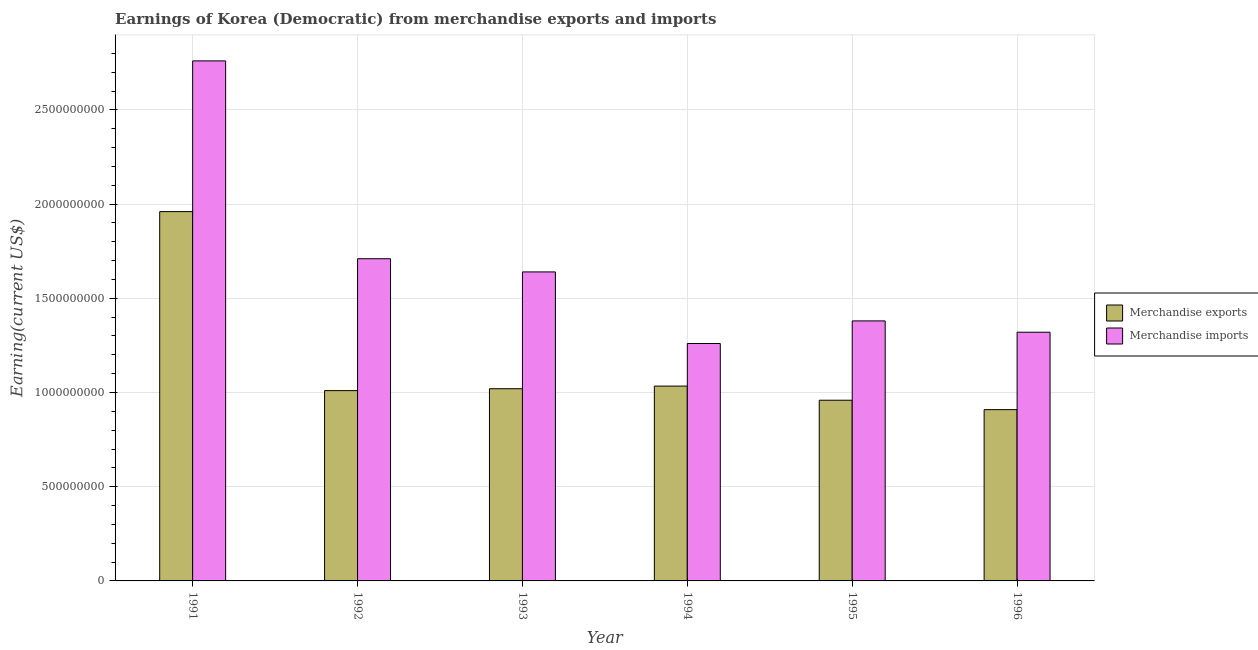Are the number of bars per tick equal to the number of legend labels?
Ensure brevity in your answer.  Yes. Are the number of bars on each tick of the X-axis equal?
Keep it short and to the point. Yes. How many bars are there on the 4th tick from the left?
Your answer should be compact. 2. What is the earnings from merchandise imports in 1993?
Offer a terse response. 1.64e+09. Across all years, what is the maximum earnings from merchandise imports?
Your answer should be compact. 2.76e+09. Across all years, what is the minimum earnings from merchandise exports?
Provide a succinct answer. 9.09e+08. In which year was the earnings from merchandise exports maximum?
Ensure brevity in your answer.  1991. In which year was the earnings from merchandise imports minimum?
Your answer should be very brief. 1994. What is the total earnings from merchandise exports in the graph?
Provide a succinct answer. 6.89e+09. What is the difference between the earnings from merchandise imports in 1994 and that in 1995?
Keep it short and to the point. -1.20e+08. What is the difference between the earnings from merchandise imports in 1994 and the earnings from merchandise exports in 1993?
Offer a very short reply. -3.80e+08. What is the average earnings from merchandise imports per year?
Your answer should be compact. 1.68e+09. In the year 1991, what is the difference between the earnings from merchandise exports and earnings from merchandise imports?
Offer a very short reply. 0. What is the ratio of the earnings from merchandise imports in 1993 to that in 1994?
Make the answer very short. 1.3. Is the earnings from merchandise imports in 1992 less than that in 1993?
Offer a terse response. No. What is the difference between the highest and the second highest earnings from merchandise exports?
Your response must be concise. 9.26e+08. What is the difference between the highest and the lowest earnings from merchandise imports?
Provide a short and direct response. 1.50e+09. In how many years, is the earnings from merchandise imports greater than the average earnings from merchandise imports taken over all years?
Give a very brief answer. 2. What does the 1st bar from the left in 1995 represents?
Keep it short and to the point. Merchandise exports. What does the 2nd bar from the right in 1995 represents?
Your answer should be very brief. Merchandise exports. How many bars are there?
Your answer should be very brief. 12. Are all the bars in the graph horizontal?
Your response must be concise. No. Does the graph contain grids?
Provide a succinct answer. Yes. How many legend labels are there?
Offer a terse response. 2. What is the title of the graph?
Give a very brief answer. Earnings of Korea (Democratic) from merchandise exports and imports. What is the label or title of the Y-axis?
Your answer should be compact. Earning(current US$). What is the Earning(current US$) of Merchandise exports in 1991?
Provide a succinct answer. 1.96e+09. What is the Earning(current US$) of Merchandise imports in 1991?
Provide a short and direct response. 2.76e+09. What is the Earning(current US$) of Merchandise exports in 1992?
Provide a short and direct response. 1.01e+09. What is the Earning(current US$) of Merchandise imports in 1992?
Offer a terse response. 1.71e+09. What is the Earning(current US$) in Merchandise exports in 1993?
Offer a terse response. 1.02e+09. What is the Earning(current US$) of Merchandise imports in 1993?
Provide a short and direct response. 1.64e+09. What is the Earning(current US$) in Merchandise exports in 1994?
Keep it short and to the point. 1.03e+09. What is the Earning(current US$) of Merchandise imports in 1994?
Offer a terse response. 1.26e+09. What is the Earning(current US$) in Merchandise exports in 1995?
Provide a succinct answer. 9.59e+08. What is the Earning(current US$) in Merchandise imports in 1995?
Your response must be concise. 1.38e+09. What is the Earning(current US$) in Merchandise exports in 1996?
Offer a terse response. 9.09e+08. What is the Earning(current US$) of Merchandise imports in 1996?
Offer a very short reply. 1.32e+09. Across all years, what is the maximum Earning(current US$) in Merchandise exports?
Offer a very short reply. 1.96e+09. Across all years, what is the maximum Earning(current US$) in Merchandise imports?
Give a very brief answer. 2.76e+09. Across all years, what is the minimum Earning(current US$) of Merchandise exports?
Your answer should be very brief. 9.09e+08. Across all years, what is the minimum Earning(current US$) of Merchandise imports?
Provide a short and direct response. 1.26e+09. What is the total Earning(current US$) in Merchandise exports in the graph?
Make the answer very short. 6.89e+09. What is the total Earning(current US$) in Merchandise imports in the graph?
Make the answer very short. 1.01e+1. What is the difference between the Earning(current US$) in Merchandise exports in 1991 and that in 1992?
Provide a succinct answer. 9.50e+08. What is the difference between the Earning(current US$) of Merchandise imports in 1991 and that in 1992?
Your answer should be compact. 1.05e+09. What is the difference between the Earning(current US$) of Merchandise exports in 1991 and that in 1993?
Keep it short and to the point. 9.40e+08. What is the difference between the Earning(current US$) in Merchandise imports in 1991 and that in 1993?
Your answer should be very brief. 1.12e+09. What is the difference between the Earning(current US$) of Merchandise exports in 1991 and that in 1994?
Provide a succinct answer. 9.26e+08. What is the difference between the Earning(current US$) in Merchandise imports in 1991 and that in 1994?
Your response must be concise. 1.50e+09. What is the difference between the Earning(current US$) in Merchandise exports in 1991 and that in 1995?
Make the answer very short. 1.00e+09. What is the difference between the Earning(current US$) in Merchandise imports in 1991 and that in 1995?
Make the answer very short. 1.38e+09. What is the difference between the Earning(current US$) of Merchandise exports in 1991 and that in 1996?
Offer a terse response. 1.05e+09. What is the difference between the Earning(current US$) of Merchandise imports in 1991 and that in 1996?
Your response must be concise. 1.44e+09. What is the difference between the Earning(current US$) in Merchandise exports in 1992 and that in 1993?
Ensure brevity in your answer.  -1.00e+07. What is the difference between the Earning(current US$) of Merchandise imports in 1992 and that in 1993?
Offer a terse response. 7.00e+07. What is the difference between the Earning(current US$) in Merchandise exports in 1992 and that in 1994?
Offer a terse response. -2.40e+07. What is the difference between the Earning(current US$) of Merchandise imports in 1992 and that in 1994?
Offer a terse response. 4.50e+08. What is the difference between the Earning(current US$) in Merchandise exports in 1992 and that in 1995?
Provide a short and direct response. 5.10e+07. What is the difference between the Earning(current US$) of Merchandise imports in 1992 and that in 1995?
Provide a succinct answer. 3.30e+08. What is the difference between the Earning(current US$) of Merchandise exports in 1992 and that in 1996?
Offer a terse response. 1.01e+08. What is the difference between the Earning(current US$) of Merchandise imports in 1992 and that in 1996?
Your answer should be compact. 3.90e+08. What is the difference between the Earning(current US$) of Merchandise exports in 1993 and that in 1994?
Your response must be concise. -1.40e+07. What is the difference between the Earning(current US$) of Merchandise imports in 1993 and that in 1994?
Make the answer very short. 3.80e+08. What is the difference between the Earning(current US$) in Merchandise exports in 1993 and that in 1995?
Provide a succinct answer. 6.10e+07. What is the difference between the Earning(current US$) in Merchandise imports in 1993 and that in 1995?
Give a very brief answer. 2.60e+08. What is the difference between the Earning(current US$) in Merchandise exports in 1993 and that in 1996?
Provide a short and direct response. 1.11e+08. What is the difference between the Earning(current US$) of Merchandise imports in 1993 and that in 1996?
Make the answer very short. 3.20e+08. What is the difference between the Earning(current US$) in Merchandise exports in 1994 and that in 1995?
Give a very brief answer. 7.50e+07. What is the difference between the Earning(current US$) of Merchandise imports in 1994 and that in 1995?
Give a very brief answer. -1.20e+08. What is the difference between the Earning(current US$) of Merchandise exports in 1994 and that in 1996?
Ensure brevity in your answer.  1.25e+08. What is the difference between the Earning(current US$) in Merchandise imports in 1994 and that in 1996?
Make the answer very short. -6.00e+07. What is the difference between the Earning(current US$) of Merchandise exports in 1995 and that in 1996?
Ensure brevity in your answer.  5.00e+07. What is the difference between the Earning(current US$) of Merchandise imports in 1995 and that in 1996?
Provide a short and direct response. 6.00e+07. What is the difference between the Earning(current US$) of Merchandise exports in 1991 and the Earning(current US$) of Merchandise imports in 1992?
Your response must be concise. 2.50e+08. What is the difference between the Earning(current US$) of Merchandise exports in 1991 and the Earning(current US$) of Merchandise imports in 1993?
Offer a terse response. 3.20e+08. What is the difference between the Earning(current US$) of Merchandise exports in 1991 and the Earning(current US$) of Merchandise imports in 1994?
Keep it short and to the point. 7.00e+08. What is the difference between the Earning(current US$) of Merchandise exports in 1991 and the Earning(current US$) of Merchandise imports in 1995?
Your answer should be compact. 5.80e+08. What is the difference between the Earning(current US$) of Merchandise exports in 1991 and the Earning(current US$) of Merchandise imports in 1996?
Ensure brevity in your answer.  6.40e+08. What is the difference between the Earning(current US$) in Merchandise exports in 1992 and the Earning(current US$) in Merchandise imports in 1993?
Provide a short and direct response. -6.30e+08. What is the difference between the Earning(current US$) of Merchandise exports in 1992 and the Earning(current US$) of Merchandise imports in 1994?
Your answer should be very brief. -2.50e+08. What is the difference between the Earning(current US$) in Merchandise exports in 1992 and the Earning(current US$) in Merchandise imports in 1995?
Your response must be concise. -3.70e+08. What is the difference between the Earning(current US$) in Merchandise exports in 1992 and the Earning(current US$) in Merchandise imports in 1996?
Give a very brief answer. -3.10e+08. What is the difference between the Earning(current US$) in Merchandise exports in 1993 and the Earning(current US$) in Merchandise imports in 1994?
Your answer should be compact. -2.40e+08. What is the difference between the Earning(current US$) of Merchandise exports in 1993 and the Earning(current US$) of Merchandise imports in 1995?
Ensure brevity in your answer.  -3.60e+08. What is the difference between the Earning(current US$) of Merchandise exports in 1993 and the Earning(current US$) of Merchandise imports in 1996?
Provide a succinct answer. -3.00e+08. What is the difference between the Earning(current US$) of Merchandise exports in 1994 and the Earning(current US$) of Merchandise imports in 1995?
Your response must be concise. -3.46e+08. What is the difference between the Earning(current US$) of Merchandise exports in 1994 and the Earning(current US$) of Merchandise imports in 1996?
Your answer should be compact. -2.86e+08. What is the difference between the Earning(current US$) of Merchandise exports in 1995 and the Earning(current US$) of Merchandise imports in 1996?
Make the answer very short. -3.61e+08. What is the average Earning(current US$) of Merchandise exports per year?
Offer a terse response. 1.15e+09. What is the average Earning(current US$) of Merchandise imports per year?
Provide a short and direct response. 1.68e+09. In the year 1991, what is the difference between the Earning(current US$) of Merchandise exports and Earning(current US$) of Merchandise imports?
Give a very brief answer. -8.00e+08. In the year 1992, what is the difference between the Earning(current US$) of Merchandise exports and Earning(current US$) of Merchandise imports?
Give a very brief answer. -7.00e+08. In the year 1993, what is the difference between the Earning(current US$) in Merchandise exports and Earning(current US$) in Merchandise imports?
Ensure brevity in your answer.  -6.20e+08. In the year 1994, what is the difference between the Earning(current US$) in Merchandise exports and Earning(current US$) in Merchandise imports?
Provide a short and direct response. -2.26e+08. In the year 1995, what is the difference between the Earning(current US$) of Merchandise exports and Earning(current US$) of Merchandise imports?
Offer a terse response. -4.21e+08. In the year 1996, what is the difference between the Earning(current US$) in Merchandise exports and Earning(current US$) in Merchandise imports?
Provide a short and direct response. -4.11e+08. What is the ratio of the Earning(current US$) of Merchandise exports in 1991 to that in 1992?
Provide a short and direct response. 1.94. What is the ratio of the Earning(current US$) in Merchandise imports in 1991 to that in 1992?
Keep it short and to the point. 1.61. What is the ratio of the Earning(current US$) in Merchandise exports in 1991 to that in 1993?
Give a very brief answer. 1.92. What is the ratio of the Earning(current US$) in Merchandise imports in 1991 to that in 1993?
Give a very brief answer. 1.68. What is the ratio of the Earning(current US$) of Merchandise exports in 1991 to that in 1994?
Make the answer very short. 1.9. What is the ratio of the Earning(current US$) of Merchandise imports in 1991 to that in 1994?
Your answer should be very brief. 2.19. What is the ratio of the Earning(current US$) of Merchandise exports in 1991 to that in 1995?
Your answer should be very brief. 2.04. What is the ratio of the Earning(current US$) in Merchandise exports in 1991 to that in 1996?
Provide a short and direct response. 2.16. What is the ratio of the Earning(current US$) in Merchandise imports in 1991 to that in 1996?
Offer a very short reply. 2.09. What is the ratio of the Earning(current US$) of Merchandise exports in 1992 to that in 1993?
Ensure brevity in your answer.  0.99. What is the ratio of the Earning(current US$) in Merchandise imports in 1992 to that in 1993?
Give a very brief answer. 1.04. What is the ratio of the Earning(current US$) of Merchandise exports in 1992 to that in 1994?
Offer a very short reply. 0.98. What is the ratio of the Earning(current US$) in Merchandise imports in 1992 to that in 1994?
Provide a short and direct response. 1.36. What is the ratio of the Earning(current US$) of Merchandise exports in 1992 to that in 1995?
Offer a very short reply. 1.05. What is the ratio of the Earning(current US$) of Merchandise imports in 1992 to that in 1995?
Your answer should be very brief. 1.24. What is the ratio of the Earning(current US$) of Merchandise imports in 1992 to that in 1996?
Give a very brief answer. 1.3. What is the ratio of the Earning(current US$) in Merchandise exports in 1993 to that in 1994?
Your answer should be compact. 0.99. What is the ratio of the Earning(current US$) of Merchandise imports in 1993 to that in 1994?
Your answer should be compact. 1.3. What is the ratio of the Earning(current US$) of Merchandise exports in 1993 to that in 1995?
Give a very brief answer. 1.06. What is the ratio of the Earning(current US$) in Merchandise imports in 1993 to that in 1995?
Offer a terse response. 1.19. What is the ratio of the Earning(current US$) of Merchandise exports in 1993 to that in 1996?
Provide a succinct answer. 1.12. What is the ratio of the Earning(current US$) in Merchandise imports in 1993 to that in 1996?
Offer a very short reply. 1.24. What is the ratio of the Earning(current US$) in Merchandise exports in 1994 to that in 1995?
Ensure brevity in your answer.  1.08. What is the ratio of the Earning(current US$) of Merchandise exports in 1994 to that in 1996?
Give a very brief answer. 1.14. What is the ratio of the Earning(current US$) in Merchandise imports in 1994 to that in 1996?
Your answer should be compact. 0.95. What is the ratio of the Earning(current US$) of Merchandise exports in 1995 to that in 1996?
Ensure brevity in your answer.  1.05. What is the ratio of the Earning(current US$) in Merchandise imports in 1995 to that in 1996?
Your response must be concise. 1.05. What is the difference between the highest and the second highest Earning(current US$) of Merchandise exports?
Ensure brevity in your answer.  9.26e+08. What is the difference between the highest and the second highest Earning(current US$) of Merchandise imports?
Give a very brief answer. 1.05e+09. What is the difference between the highest and the lowest Earning(current US$) of Merchandise exports?
Make the answer very short. 1.05e+09. What is the difference between the highest and the lowest Earning(current US$) of Merchandise imports?
Provide a succinct answer. 1.50e+09. 